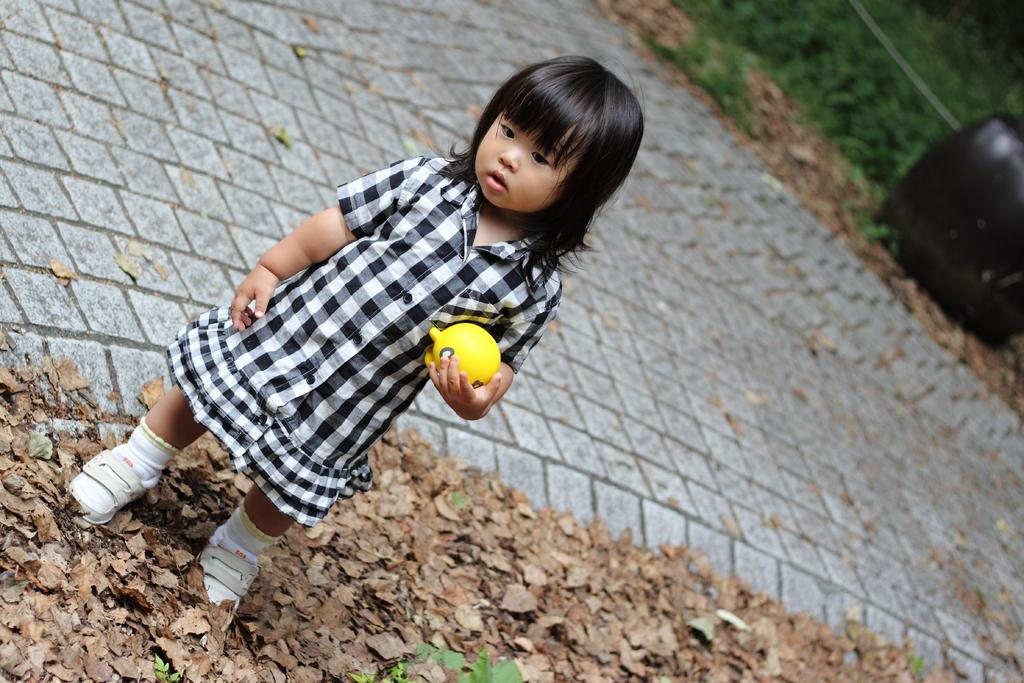What is the main subject of the image? There is a baby in the image. What is the baby standing beside? The baby is standing beside dry leaves. What is the baby holding in her hand? The baby is holding a ball with her hand. How would you describe the background of the image? The background of the image is blurry. What type of pump can be seen in the image? There is no pump present in the image. What kind of crack is visible on the baby's face in the image? There is no crack visible on the baby's face in the image. 